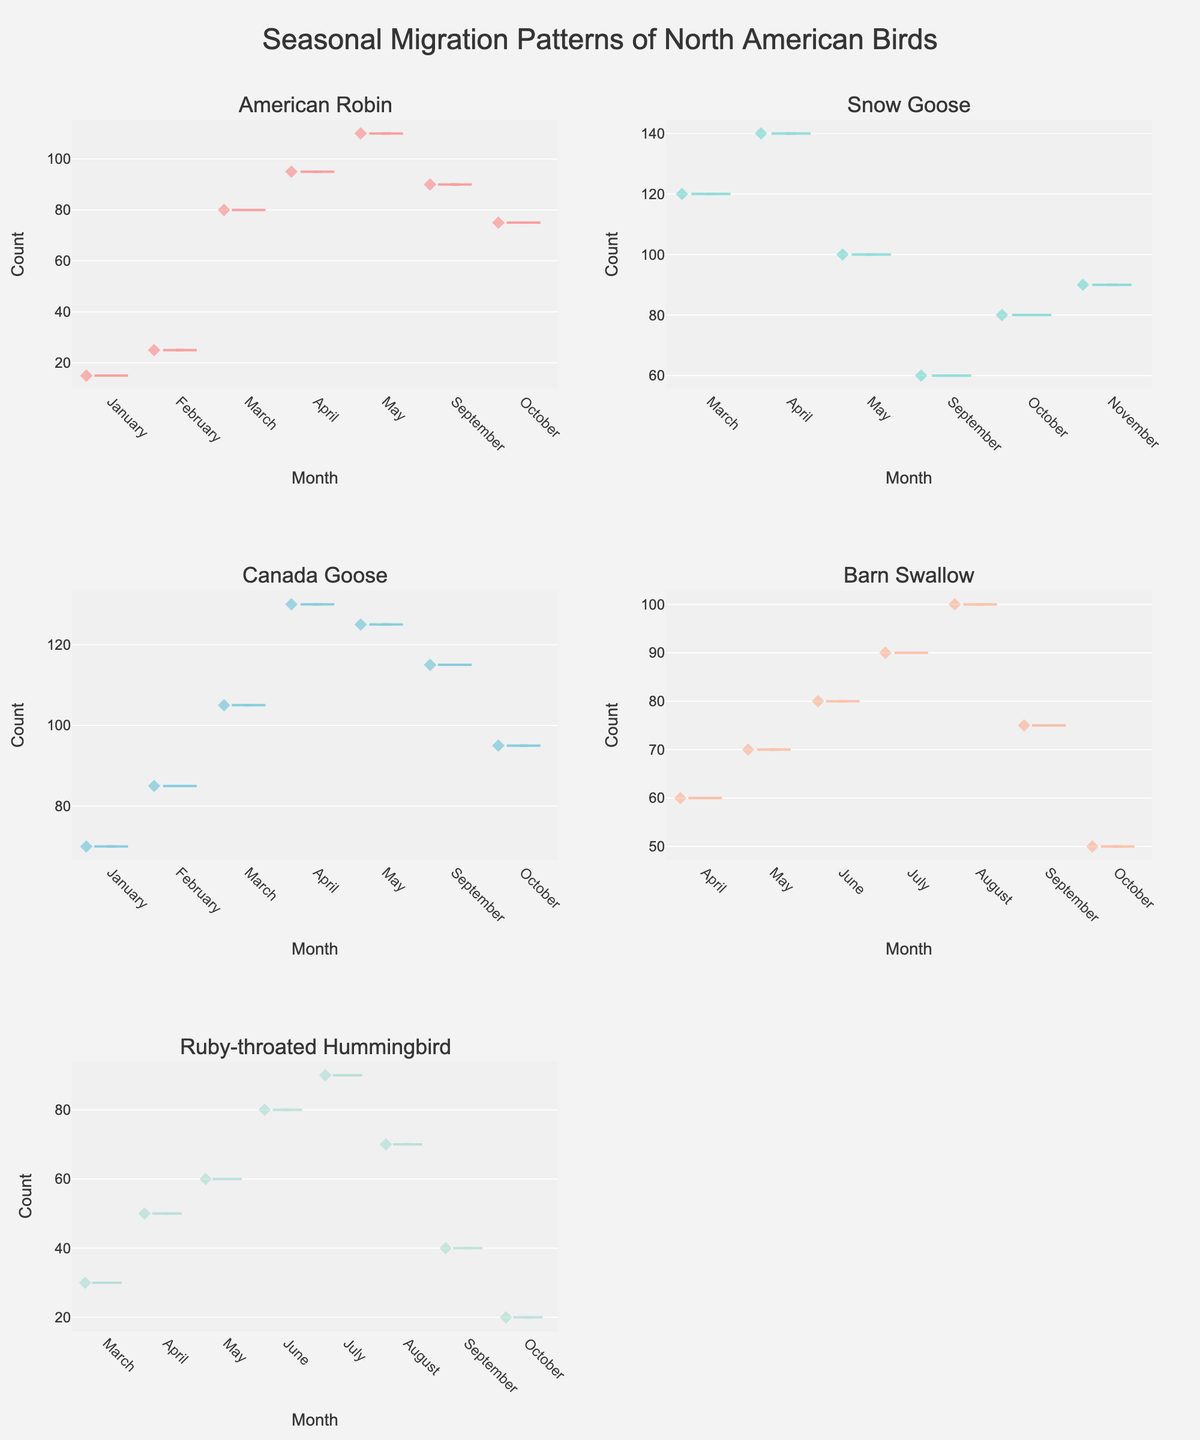What is the title of the figure? The title of the entire plot is usually prominently displayed at the top. In this case, it reads "Seasonal Migration Patterns of North American Birds".
Answer: Seasonal Migration Patterns of North American Birds Which bird species has the highest count in April? Each subplot is associated with a different bird species. By looking at the April data points across all subplots, we identify which plot has the highest value for that month. For April, the "Canada Goose" subplot shows the highest count (130).
Answer: Canada Goose How does the count of Barn Swallows in August compare to that in October? To compare the counts, check the data points for Barn Swallows in August and October. In August, the count is 100, and in October, it is 50. 100 is greater than 50.
Answer: 100 is greater than 50 What is the total count for the Snow Goose in September and October? Locate the September and October data points for the Snow Goose subplot. The counts are 60 (September) and 80 (October). Summing these gives 60 + 80 = 140.
Answer: 140 Between the American Robin and the Ruby-throated Hummingbird, which species shows a higher count in May? Compare the counts in May for both species. The American Robin has a count of 110, while the Ruby-throated Hummingbird has 60. 110 is greater than 60.
Answer: American Robin What is the average count of the Snow Goose in March, April, and May? To find the average, sum the counts in March (120), April (140), and May (100), which equals 360. Then divide by 3, resulting in an average of 120.
Answer: 120 Which month shows the highest migration activity for the Canada Goose? By analyzing the Canada Goose subplot, the month with the highest count identifies the peak migration activity. The highest count is in April (130).
Answer: April How do the migration patterns of the Barn Swallow and Canada Goose in September compare? Compare September counts for both species. Barn Swallow: 75, Canada Goose: 115. The Canada Goose has a higher count, indicating more activity.
Answer: Canada Goose has higher activity What months show data points for the American Robin in the plot? Look at the x-axis (months) for the American Robin subplot to identify all the months where data points are present. These months are January, February, March, April, May, September, and October.
Answer: January, February, March, April, May, September, October 